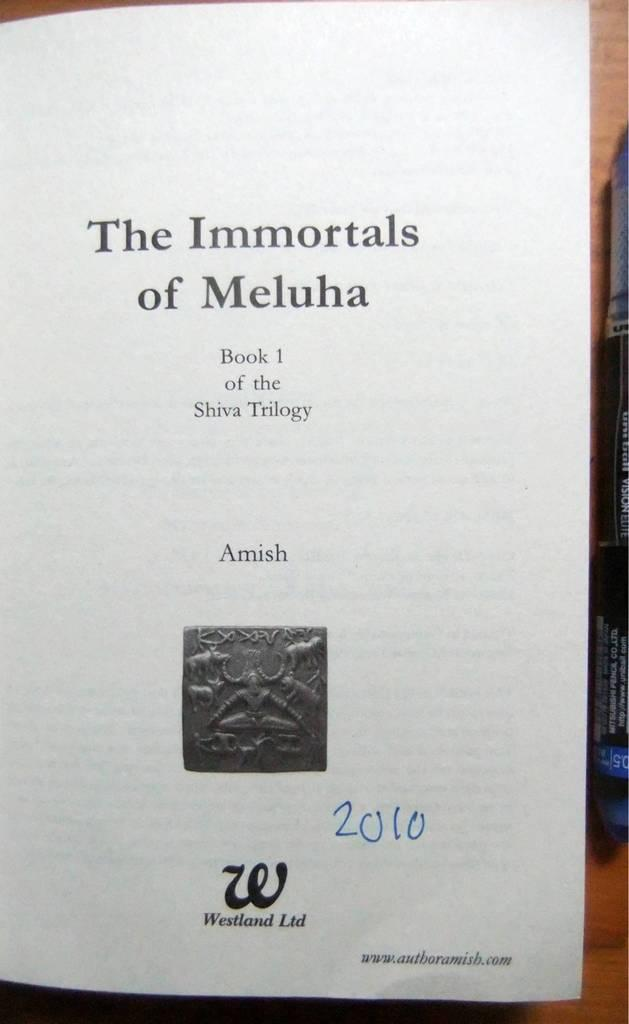Provide a one-sentence caption for the provided image. The first page of Book 1 in the Shiva Trilogy by Amish. 